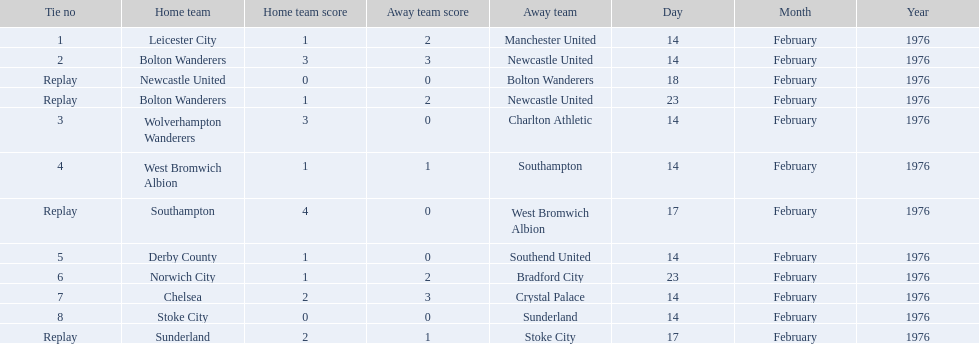What was the goal difference in the game on february 18th? 0. 